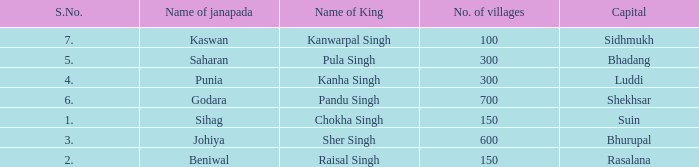What king has an S. number over 1 and a number of villages of 600? Sher Singh. 